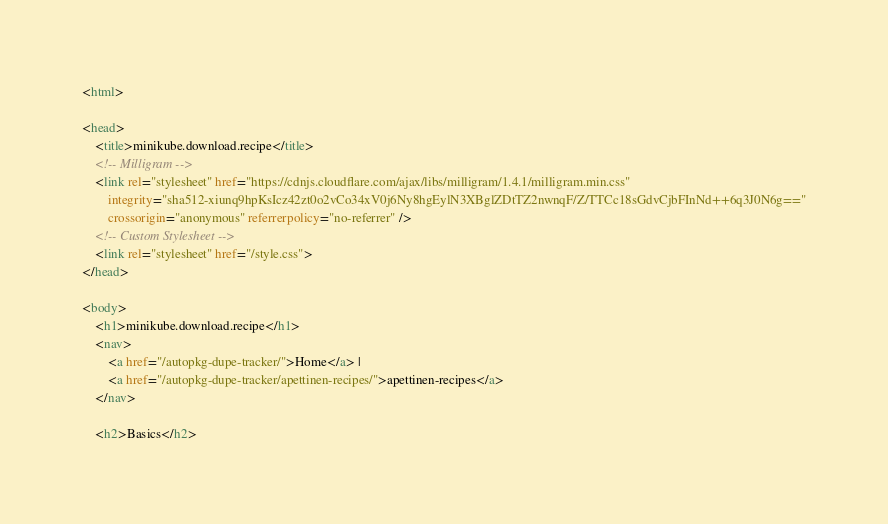<code> <loc_0><loc_0><loc_500><loc_500><_HTML_><html>

<head>
    <title>minikube.download.recipe</title>
    <!-- Milligram -->
    <link rel="stylesheet" href="https://cdnjs.cloudflare.com/ajax/libs/milligram/1.4.1/milligram.min.css"
        integrity="sha512-xiunq9hpKsIcz42zt0o2vCo34xV0j6Ny8hgEylN3XBglZDtTZ2nwnqF/Z/TTCc18sGdvCjbFInNd++6q3J0N6g=="
        crossorigin="anonymous" referrerpolicy="no-referrer" />
    <!-- Custom Stylesheet -->
    <link rel="stylesheet" href="/style.css">
</head>

<body>
    <h1>minikube.download.recipe</h1>
    <nav>
        <a href="/autopkg-dupe-tracker/">Home</a> |
        <a href="/autopkg-dupe-tracker/apettinen-recipes/">apettinen-recipes</a>
    </nav>

    <h2>Basics</h2></code> 